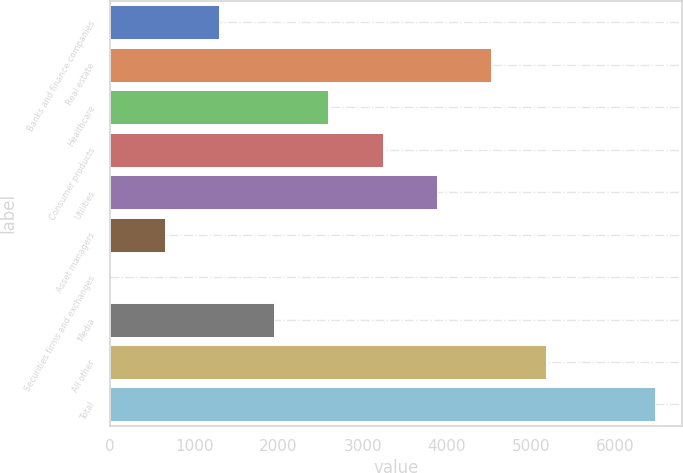<chart> <loc_0><loc_0><loc_500><loc_500><bar_chart><fcel>Banks and finance companies<fcel>Real estate<fcel>Healthcare<fcel>Consumer products<fcel>Utilities<fcel>Asset managers<fcel>Securities firms and exchanges<fcel>Media<fcel>All other<fcel>Total<nl><fcel>1297<fcel>4529.5<fcel>2590<fcel>3236.5<fcel>3883<fcel>650.5<fcel>4<fcel>1943.5<fcel>5176<fcel>6469<nl></chart> 